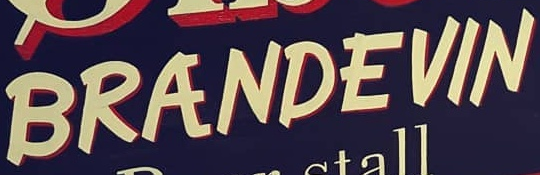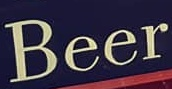What text appears in these images from left to right, separated by a semicolon? BRANDEVIN; Beer 